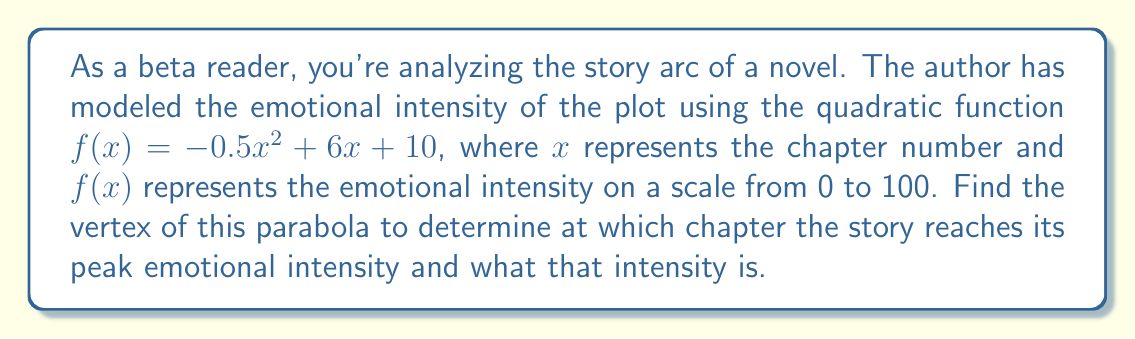Help me with this question. To find the vertex of a parabola in the form $f(x) = ax^2 + bx + c$, we can use the formula:

$x = -\frac{b}{2a}$

where $a$ and $b$ are the coefficients of $x^2$ and $x$ respectively.

In this case, $a = -0.5$ and $b = 6$.

1) First, let's calculate the x-coordinate of the vertex:

   $x = -\frac{6}{2(-0.5)} = -\frac{6}{-1} = 6$

2) To find the y-coordinate, we substitute this x-value back into the original function:

   $f(6) = -0.5(6)^2 + 6(6) + 10$
   $    = -0.5(36) + 36 + 10$
   $    = -18 + 36 + 10$
   $    = 28$

3) Therefore, the vertex is (6, 28).

This means the story reaches its peak emotional intensity at chapter 6, with an intensity of 28 on the scale of 0 to 100.
Answer: The vertex of the parabola is (6, 28), indicating that the story reaches its peak emotional intensity at chapter 6 with an intensity of 28. 